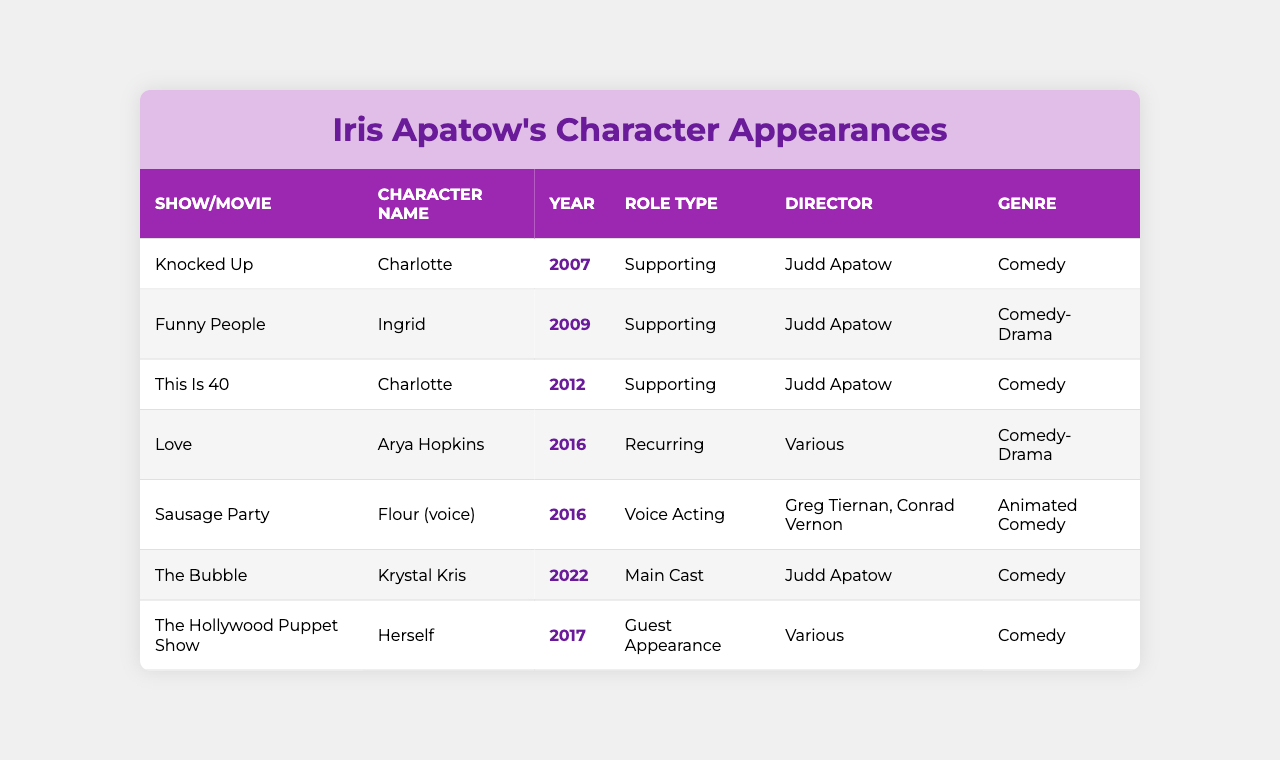What character did Iris Apatow play in "Funny People"? The table lists "Ingrid" as the character Iris Apatow played in "Funny People."
Answer: Ingrid In which year did Iris Apatow appear in "Knocked Up"? According to the table, Iris Apatow appeared in "Knocked Up" in the year 2007.
Answer: 2007 How many supporting roles did Iris Apatow play? The table shows three instances of supporting roles: Charlotte in "Knocked Up," Ingrid in "Funny People," and Charlotte in "This Is 40."
Answer: 3 Was Iris Apatow the main cast in "The Bubble"? The table indicates that Iris Apatow was indeed part of the main cast in "The Bubble."
Answer: Yes List the genres of the shows/movies in which Iris Apatow appeared. The table shows the following genres: Comedy, Comedy-Drama, Animated Comedy.
Answer: Comedy, Comedy-Drama, Animated Comedy How many different directors worked with Iris Apatow in her roles? The directors listed are Judd Apatow and various others for multiple projects. Judd is mentioned four times and various directors once. This means at least two distinct directors.
Answer: 2 In which show did Iris Apatow's character have a voice role? The table specifies "Sausage Party" as the show where Iris Apatow's character had a voice role as Flour.
Answer: Sausage Party Which character did Iris Apatow portray in both "Knocked Up" and "This Is 40"? The character is Charlotte, as indicated in both instances in the table.
Answer: Charlotte How many years apart were "Funny People" and "The Bubble"? "Funny People" was released in 2009 and "The Bubble" in 2022, which makes it 13 years apart.
Answer: 13 years Was there any instance of Iris Apatow appearing as herself in a show? Yes, the table shows that she appeared as herself in "The Hollywood Puppet Show."
Answer: Yes What is the role type of the character Arya Hopkins? The table states that Arya Hopkins is a recurring role.
Answer: Recurring 